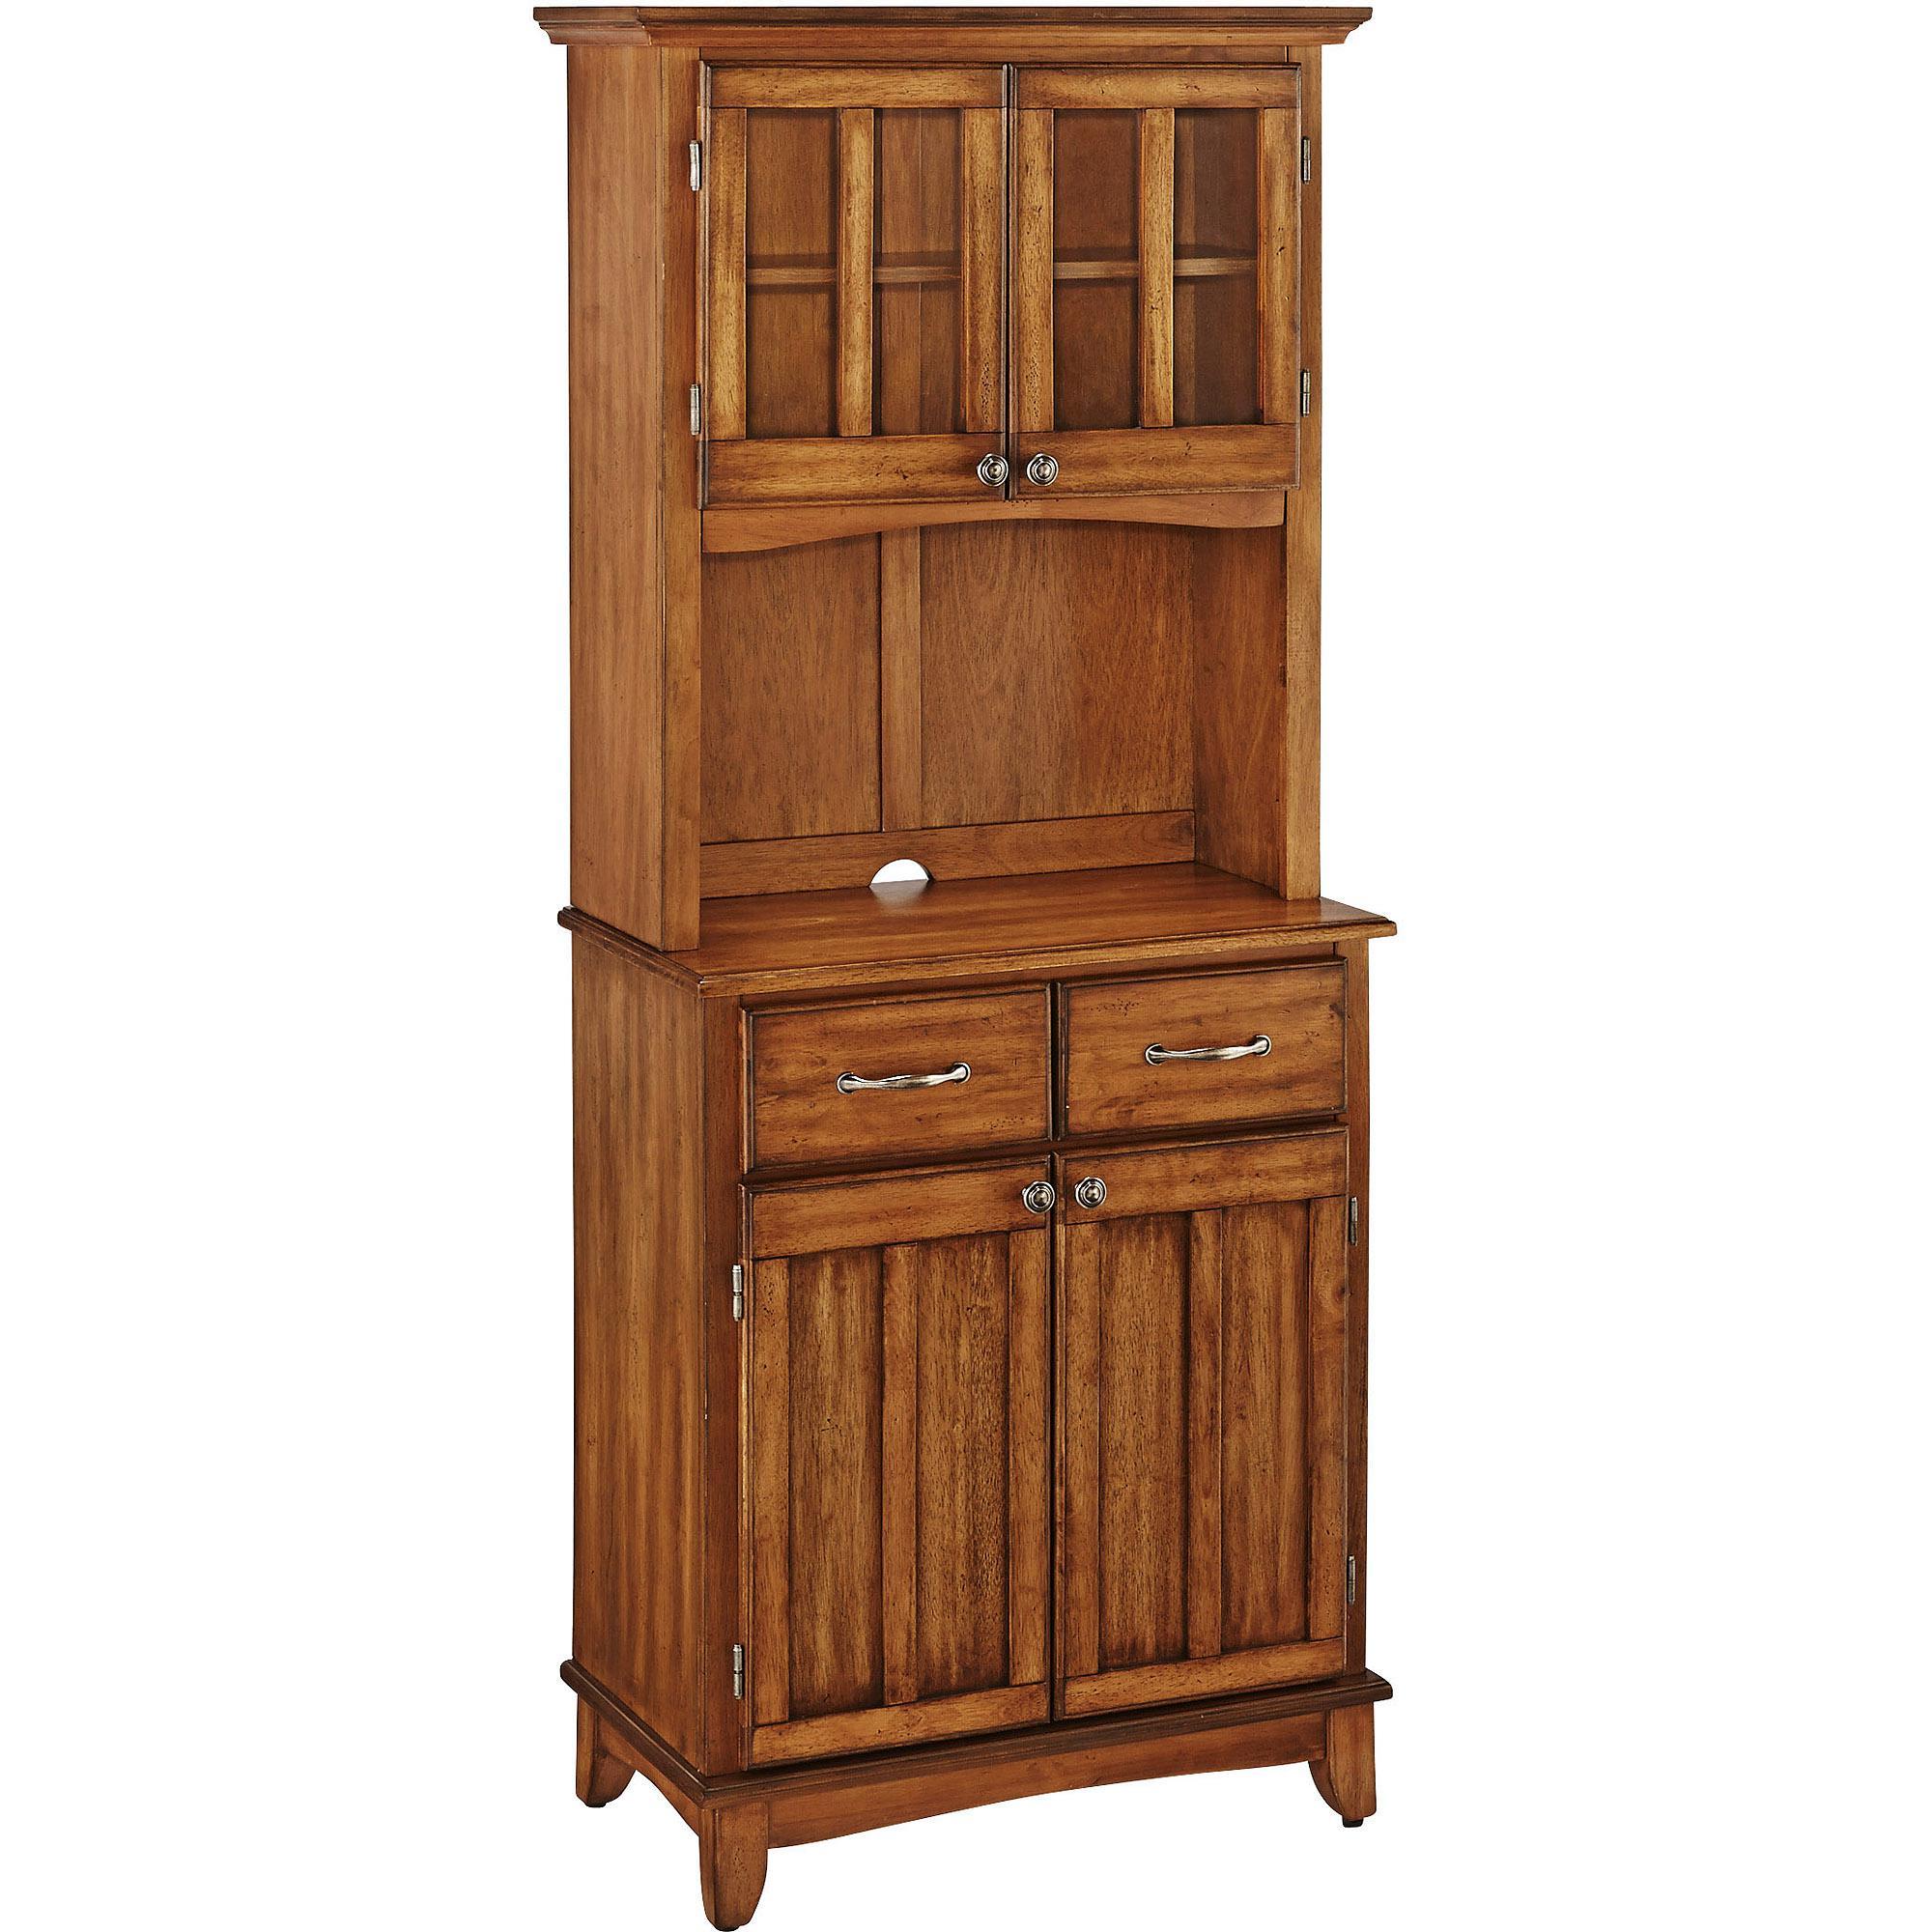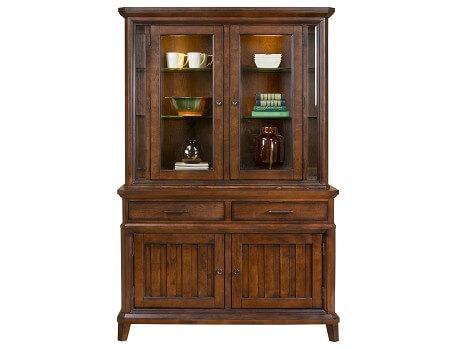The first image is the image on the left, the second image is the image on the right. Analyze the images presented: Is the assertion "One of the cabinets has a curving arched solid-wood top." valid? Answer yes or no. No. 